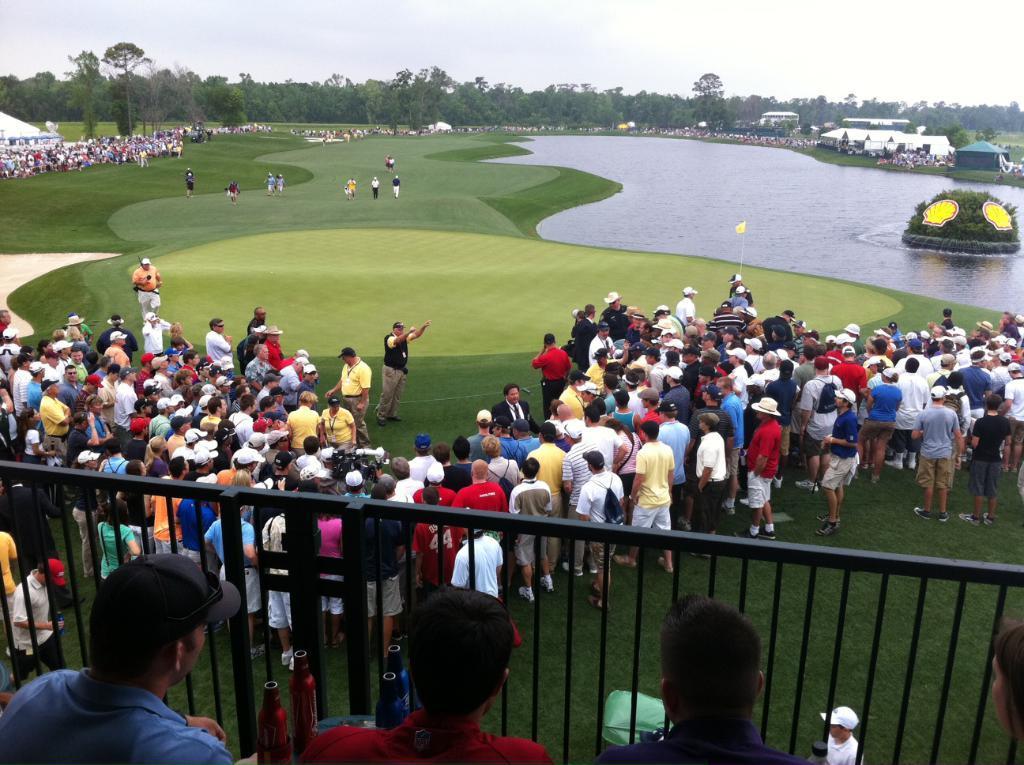Can you describe this image briefly? In this image there are a few people and two bottles, in front of them there is a railing and there are so many people standing on the ground. On the left side of the image there is a river and there is a structure with grass and some stickers on it. On the other side of the river there are also so many people standing and there are a few camps and vehicles. In the background there is the sky. 